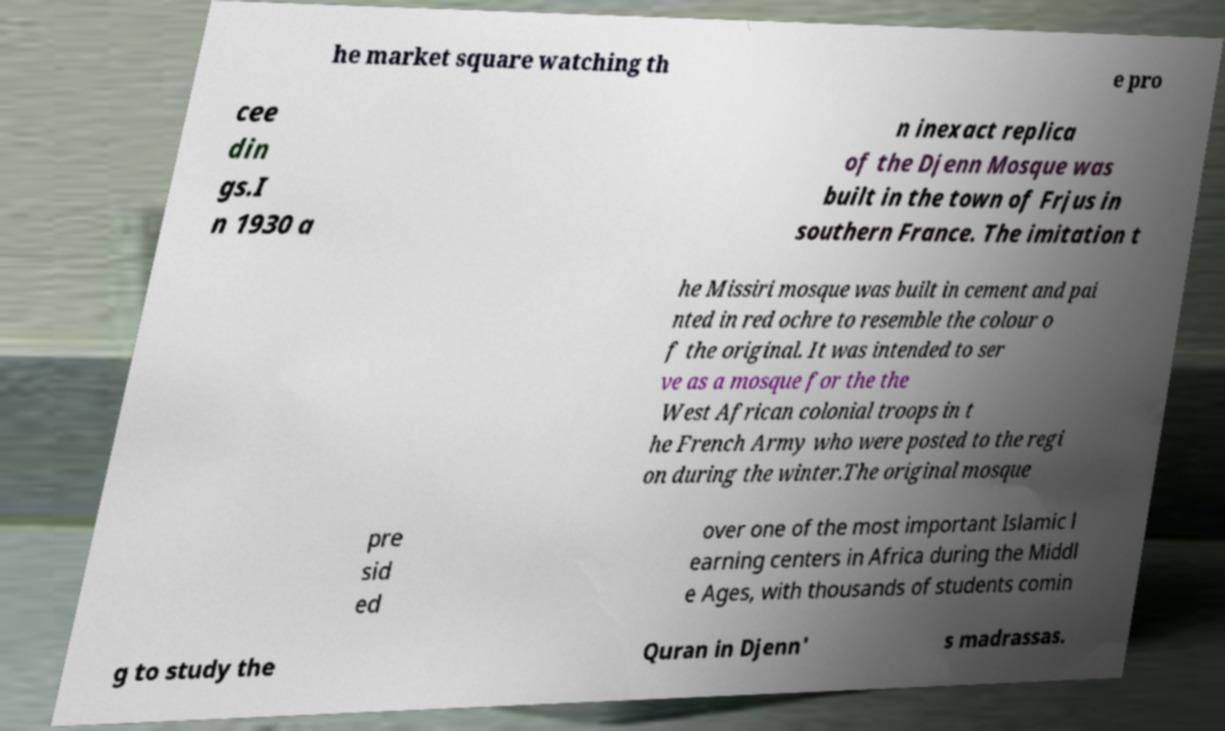Can you read and provide the text displayed in the image?This photo seems to have some interesting text. Can you extract and type it out for me? he market square watching th e pro cee din gs.I n 1930 a n inexact replica of the Djenn Mosque was built in the town of Frjus in southern France. The imitation t he Missiri mosque was built in cement and pai nted in red ochre to resemble the colour o f the original. It was intended to ser ve as a mosque for the the West African colonial troops in t he French Army who were posted to the regi on during the winter.The original mosque pre sid ed over one of the most important Islamic l earning centers in Africa during the Middl e Ages, with thousands of students comin g to study the Quran in Djenn' s madrassas. 